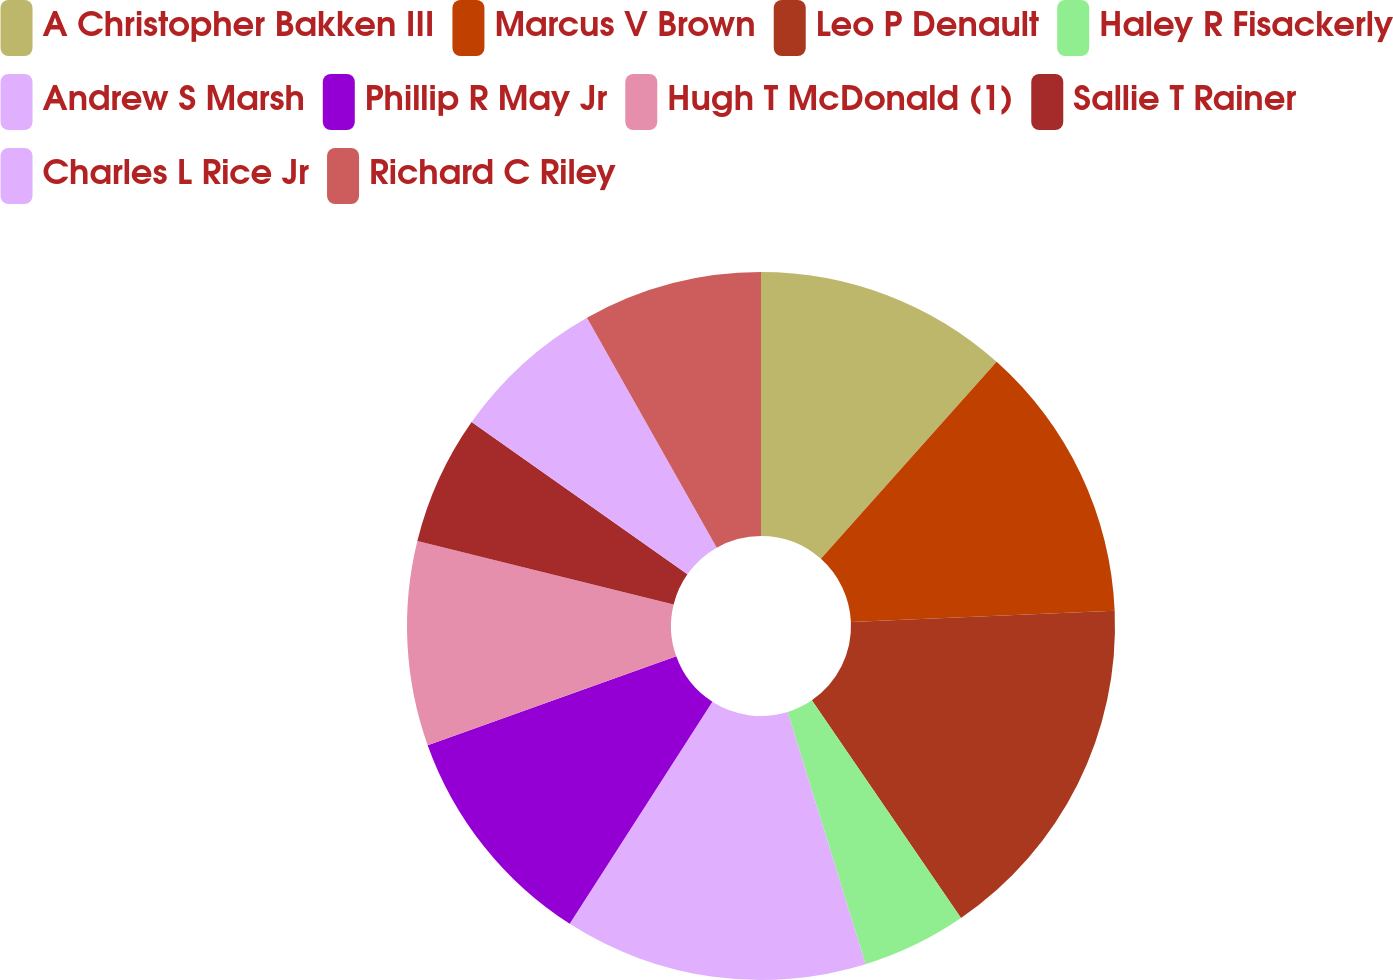<chart> <loc_0><loc_0><loc_500><loc_500><pie_chart><fcel>A Christopher Bakken III<fcel>Marcus V Brown<fcel>Leo P Denault<fcel>Haley R Fisackerly<fcel>Andrew S Marsh<fcel>Phillip R May Jr<fcel>Hugh T McDonald (1)<fcel>Sallie T Rainer<fcel>Charles L Rice Jr<fcel>Richard C Riley<nl><fcel>11.59%<fcel>12.72%<fcel>16.13%<fcel>4.78%<fcel>13.86%<fcel>10.45%<fcel>9.32%<fcel>5.91%<fcel>7.05%<fcel>8.18%<nl></chart> 